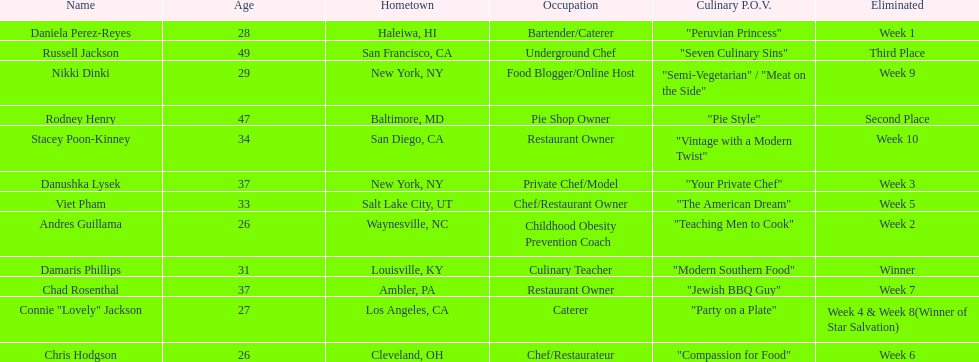Who was eliminated first, nikki dinki or viet pham? Viet Pham. 